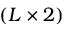<formula> <loc_0><loc_0><loc_500><loc_500>( L \times 2 )</formula> 